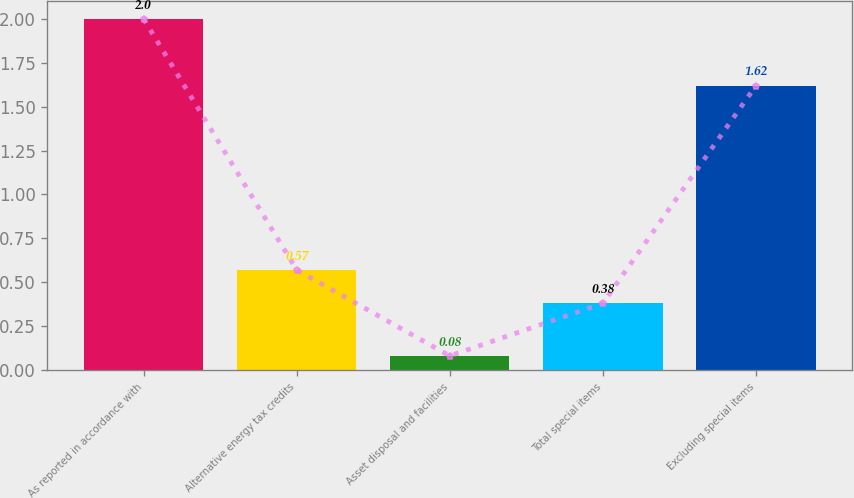Convert chart to OTSL. <chart><loc_0><loc_0><loc_500><loc_500><bar_chart><fcel>As reported in accordance with<fcel>Alternative energy tax credits<fcel>Asset disposal and facilities<fcel>Total special items<fcel>Excluding special items<nl><fcel>2<fcel>0.57<fcel>0.08<fcel>0.38<fcel>1.62<nl></chart> 